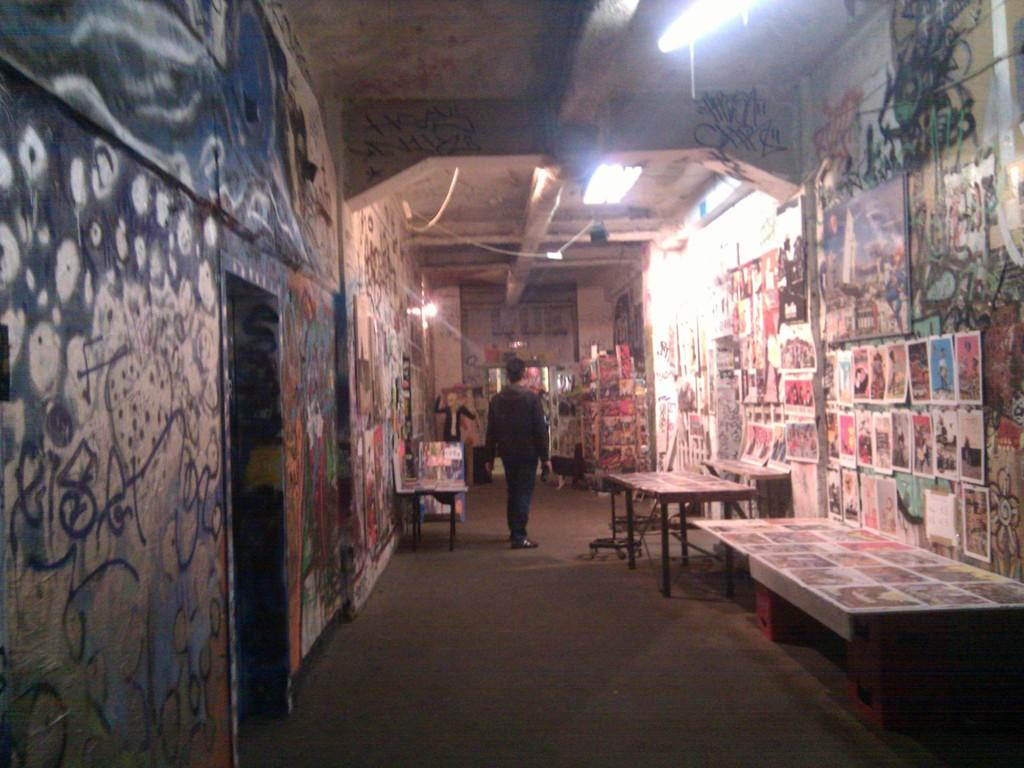What is the main subject in the image? There is a man standing in the image. Where is the man standing? The man is standing on the floor. What other objects can be seen in the image? There are tables, a wall, a painting, posters, lights, and a rack in the image. How many quarters can be seen on the floor in the image? There are no quarters visible on the floor in the image. Is there a drain present in the image? There is no drain present in the image. 